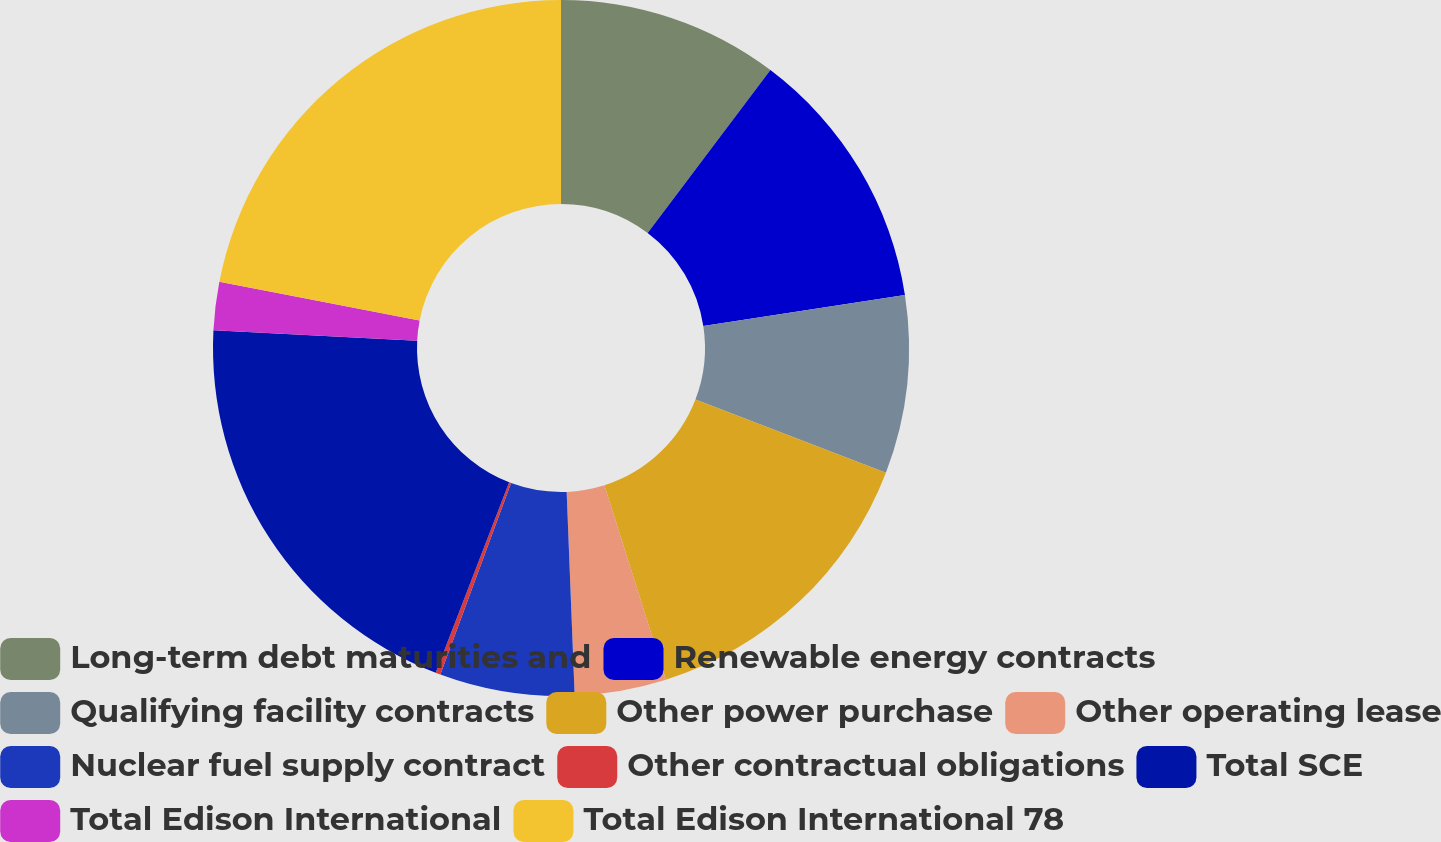<chart> <loc_0><loc_0><loc_500><loc_500><pie_chart><fcel>Long-term debt maturities and<fcel>Renewable energy contracts<fcel>Qualifying facility contracts<fcel>Other power purchase<fcel>Other operating lease<fcel>Nuclear fuel supply contract<fcel>Other contractual obligations<fcel>Total SCE<fcel>Total Edison International<fcel>Total Edison International 78<nl><fcel>10.28%<fcel>12.29%<fcel>8.27%<fcel>14.3%<fcel>4.25%<fcel>6.26%<fcel>0.23%<fcel>19.95%<fcel>2.24%<fcel>21.96%<nl></chart> 